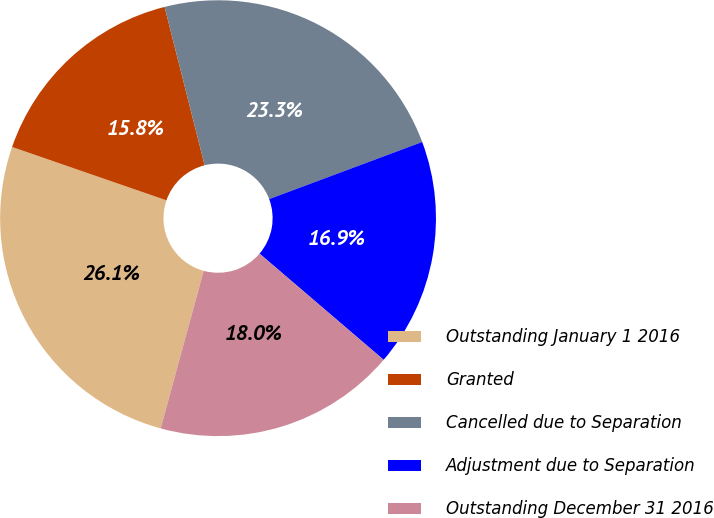Convert chart to OTSL. <chart><loc_0><loc_0><loc_500><loc_500><pie_chart><fcel>Outstanding January 1 2016<fcel>Granted<fcel>Cancelled due to Separation<fcel>Adjustment due to Separation<fcel>Outstanding December 31 2016<nl><fcel>26.06%<fcel>15.76%<fcel>23.26%<fcel>16.95%<fcel>17.98%<nl></chart> 